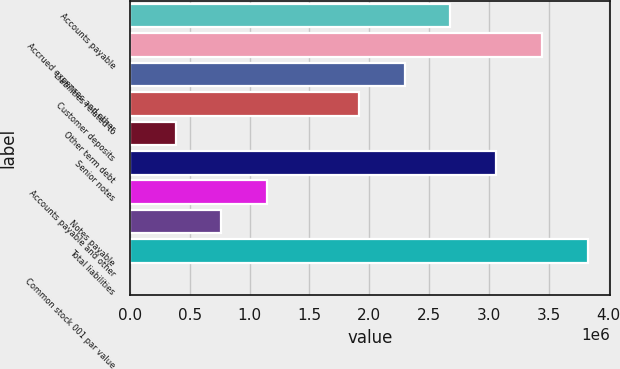Convert chart to OTSL. <chart><loc_0><loc_0><loc_500><loc_500><bar_chart><fcel>Accounts payable<fcel>Accrued expenses and other<fcel>Liabilities related to<fcel>Customer deposits<fcel>Other term debt<fcel>Senior notes<fcel>Accounts payable and other<fcel>Notes payable<fcel>Total liabilities<fcel>Common stock 001 par value<nl><fcel>2.67621e+06<fcel>3.44078e+06<fcel>2.29392e+06<fcel>1.91164e+06<fcel>382492<fcel>3.05849e+06<fcel>1.14706e+06<fcel>764778<fcel>3.82307e+06<fcel>206<nl></chart> 